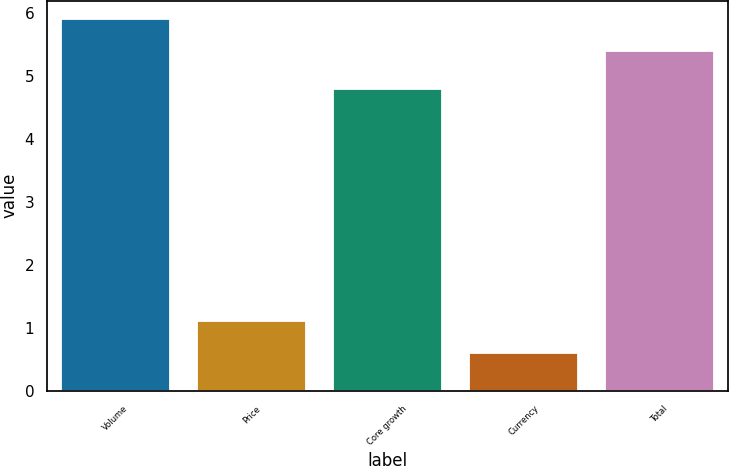Convert chart. <chart><loc_0><loc_0><loc_500><loc_500><bar_chart><fcel>Volume<fcel>Price<fcel>Core growth<fcel>Currency<fcel>Total<nl><fcel>5.9<fcel>1.1<fcel>4.8<fcel>0.6<fcel>5.4<nl></chart> 